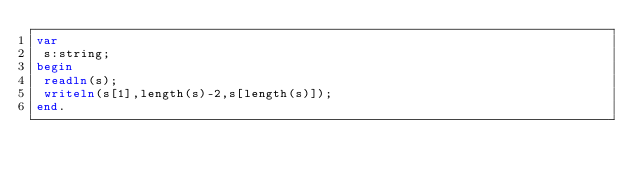<code> <loc_0><loc_0><loc_500><loc_500><_Pascal_>var
 s:string;
begin
 readln(s);
 writeln(s[1],length(s)-2,s[length(s)]);
end.</code> 